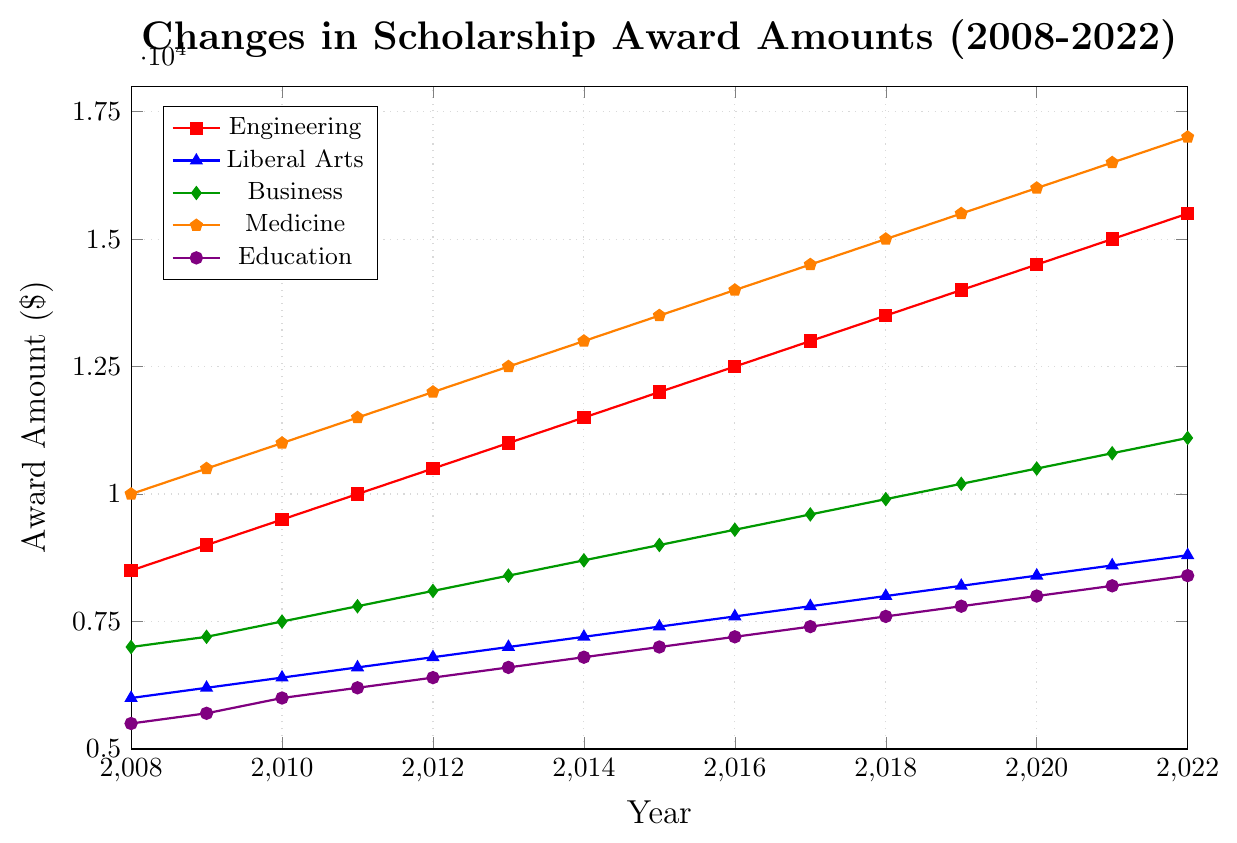Which academic discipline had the highest scholarship award amount in 2022? Locate the data points in 2022 and compare them: Engineering (15500), Liberal Arts (8800), Business (11100), Medicine (17000), Education (8400). Medicine has the highest value.
Answer: Medicine What's the difference in scholarship award amounts between Engineering and Education in 2010? Locate the data points for 2010: Engineering (9500) and Education (6000). Calculate the difference: 9500 - 6000 = 3500.
Answer: 3500 By how much did the scholarship award amount for Business increase from 2008 to 2022? Identify the data points for Business in 2008 (7000) and 2022 (11100). Calculate the increase: 11100 - 7000 = 4100.
Answer: 4100 Which discipline had the lowest scholarship award amount through most of the period? Compare the trends across all years. Education consistently had lower values compared to others throughout the period.
Answer: Education How did the scholarship award amount for Liberal Arts change from 2018 to 2022, and what was the overall increase? Identify the values for Liberal Arts in 2018 (8000) and 2022 (8800). Calculate the difference: 8800 - 8000 = 800.
Answer: 800 Between which two consecutive years did Medicine experience the largest increase in scholarship award amounts? Analyze the year-to-year increments for Medicine: each year the increase is 500. The largest consistent increase is 500 every year.
Answer: Every year (500) What is the average scholarship award amount for Business from 2008 to 2022? Sum up all Business values and divide by 15: (7000 + 7200 + 7500 + 7800 + 8100 + 8400 + 8700 + 9000 + 9300 + 9600 + 9900 + 10200 + 10500 + 10800 + 11100) / 15 = 9150.
Answer: 9150 Which discipline showed the most dramatic increase in scholarship award amounts over the 15-year period? Compare the overall increases: Engineering (15500-8500=7000), Liberal Arts (8800-6000=2800), Business (11100-7000=4100), Medicine (17000-10000=7000), Education (8400-5500=2900). Engineering and Medicine both show an increase of 7000.
Answer: Engineering and Medicine 